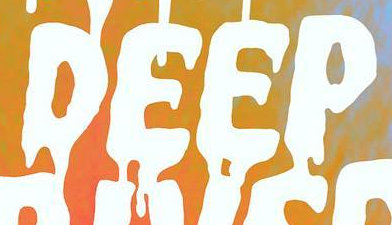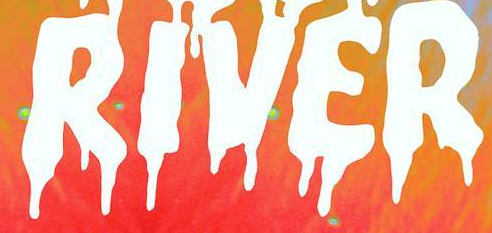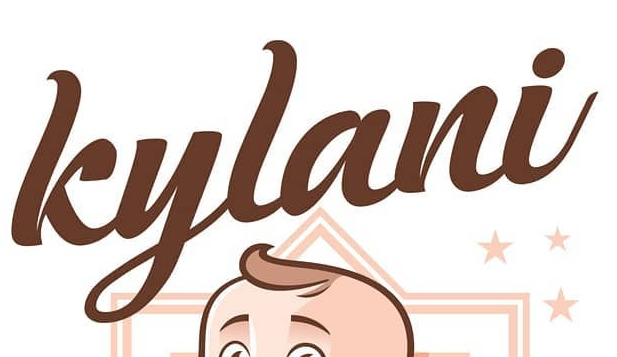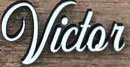Read the text from these images in sequence, separated by a semicolon. DEEP; RIVER; kylani; Victor 